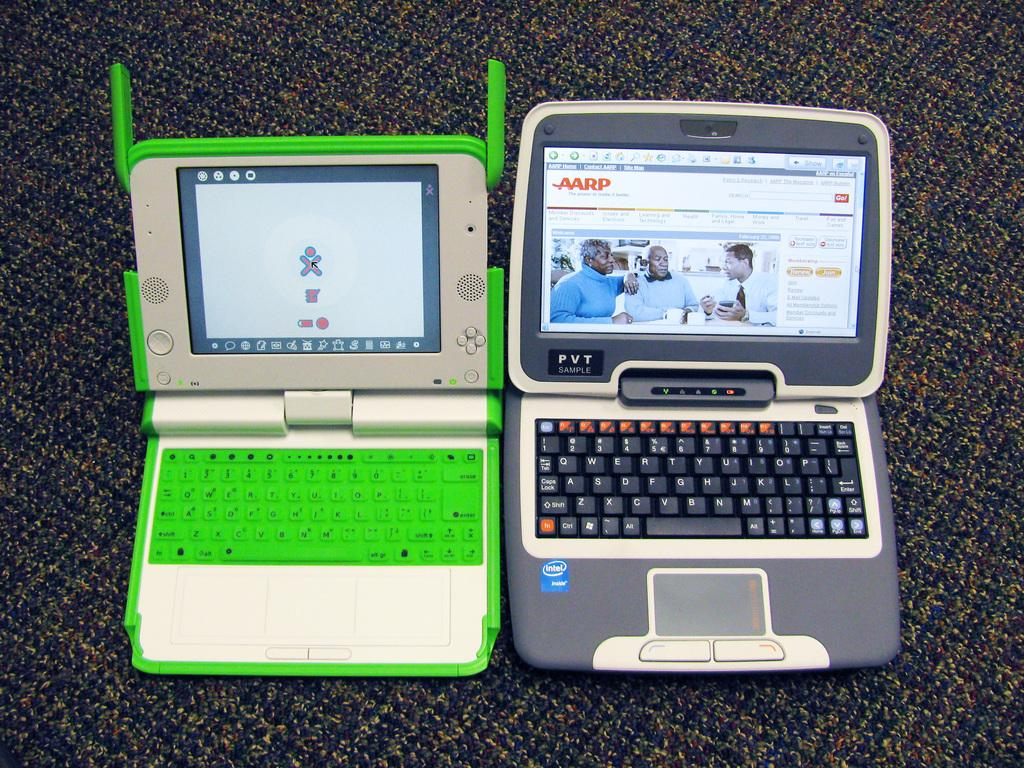<image>
Describe the image concisely. Two small laptops with one open to the AARP page. 